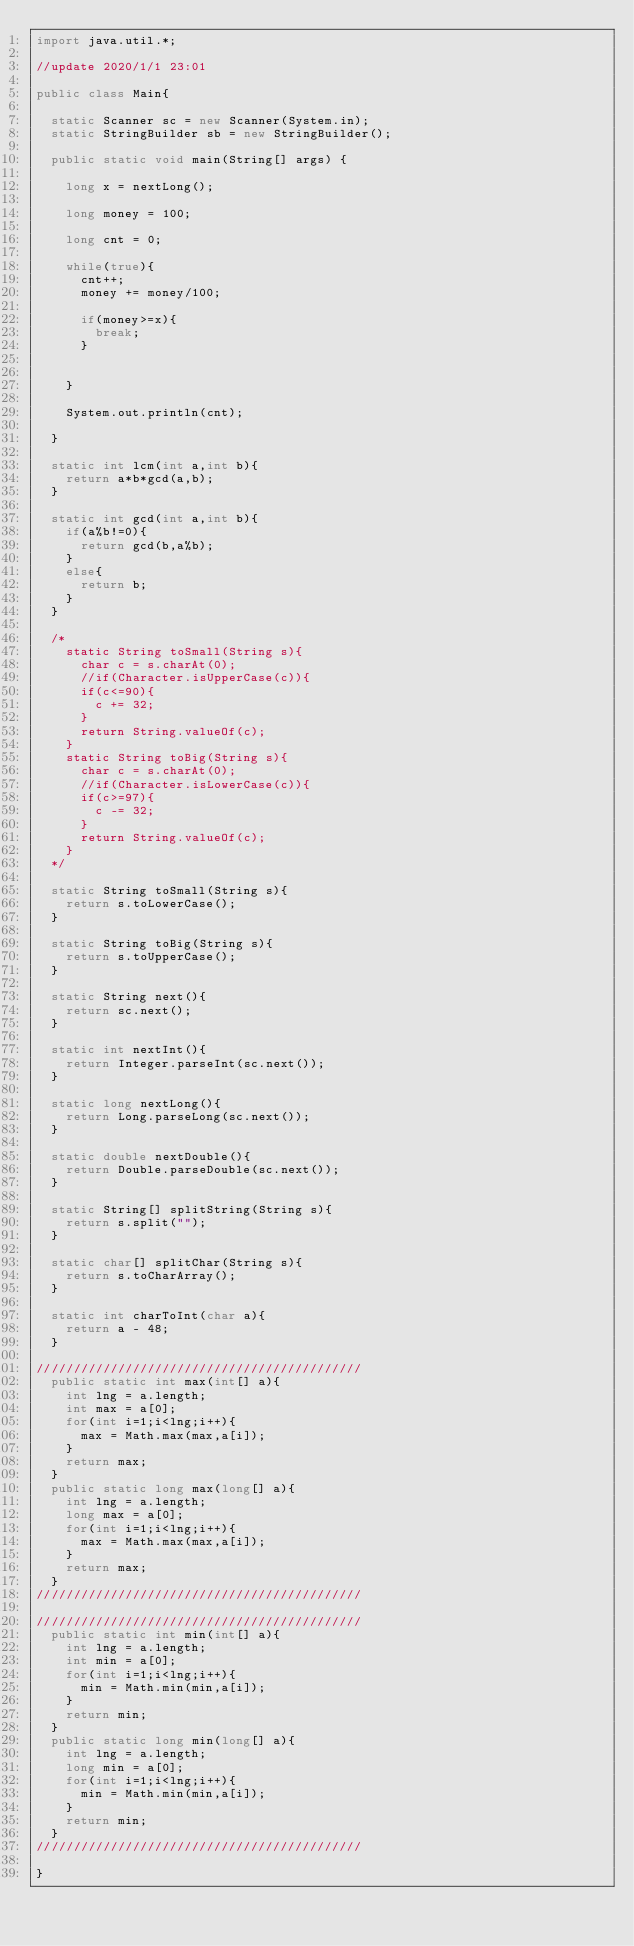<code> <loc_0><loc_0><loc_500><loc_500><_Java_>import java.util.*;

//update 2020/1/1 23:01

public class Main{

  static Scanner sc = new Scanner(System.in);
  static StringBuilder sb = new StringBuilder();

  public static void main(String[] args) {

    long x = nextLong();

    long money = 100;

    long cnt = 0;

    while(true){
      cnt++;
      money += money/100;

      if(money>=x){
        break;
      }


    }

    System.out.println(cnt);

  }

  static int lcm(int a,int b){
    return a*b*gcd(a,b);
  }

  static int gcd(int a,int b){
    if(a%b!=0){
      return gcd(b,a%b);
    }
    else{
      return b;
    }
  }

  /*
    static String toSmall(String s){
      char c = s.charAt(0);
      //if(Character.isUpperCase(c)){
      if(c<=90){
        c += 32;
      }
      return String.valueOf(c);
    }
    static String toBig(String s){
      char c = s.charAt(0);
      //if(Character.isLowerCase(c)){
      if(c>=97){
        c -= 32;
      }
      return String.valueOf(c);
    }
  */

  static String toSmall(String s){
    return s.toLowerCase();
  }

  static String toBig(String s){
    return s.toUpperCase();
  }

  static String next(){
    return sc.next();
  }

  static int nextInt(){
    return Integer.parseInt(sc.next());
  }

  static long nextLong(){
    return Long.parseLong(sc.next());
  }

  static double nextDouble(){
    return Double.parseDouble(sc.next());
  }

  static String[] splitString(String s){
    return s.split("");
  }

  static char[] splitChar(String s){
    return s.toCharArray();
  }

  static int charToInt(char a){
    return a - 48;
  }

////////////////////////////////////////////
  public static int max(int[] a){
    int lng = a.length;
    int max = a[0];
    for(int i=1;i<lng;i++){
      max = Math.max(max,a[i]);
    }
    return max;
  }
  public static long max(long[] a){
    int lng = a.length;
    long max = a[0];
    for(int i=1;i<lng;i++){
      max = Math.max(max,a[i]);
    }
    return max;
  }
////////////////////////////////////////////

////////////////////////////////////////////
  public static int min(int[] a){
    int lng = a.length;
    int min = a[0];
    for(int i=1;i<lng;i++){
      min = Math.min(min,a[i]);
    }
    return min;
  }
  public static long min(long[] a){
    int lng = a.length;
    long min = a[0];
    for(int i=1;i<lng;i++){
      min = Math.min(min,a[i]);
    }
    return min;
  }
////////////////////////////////////////////

}
</code> 